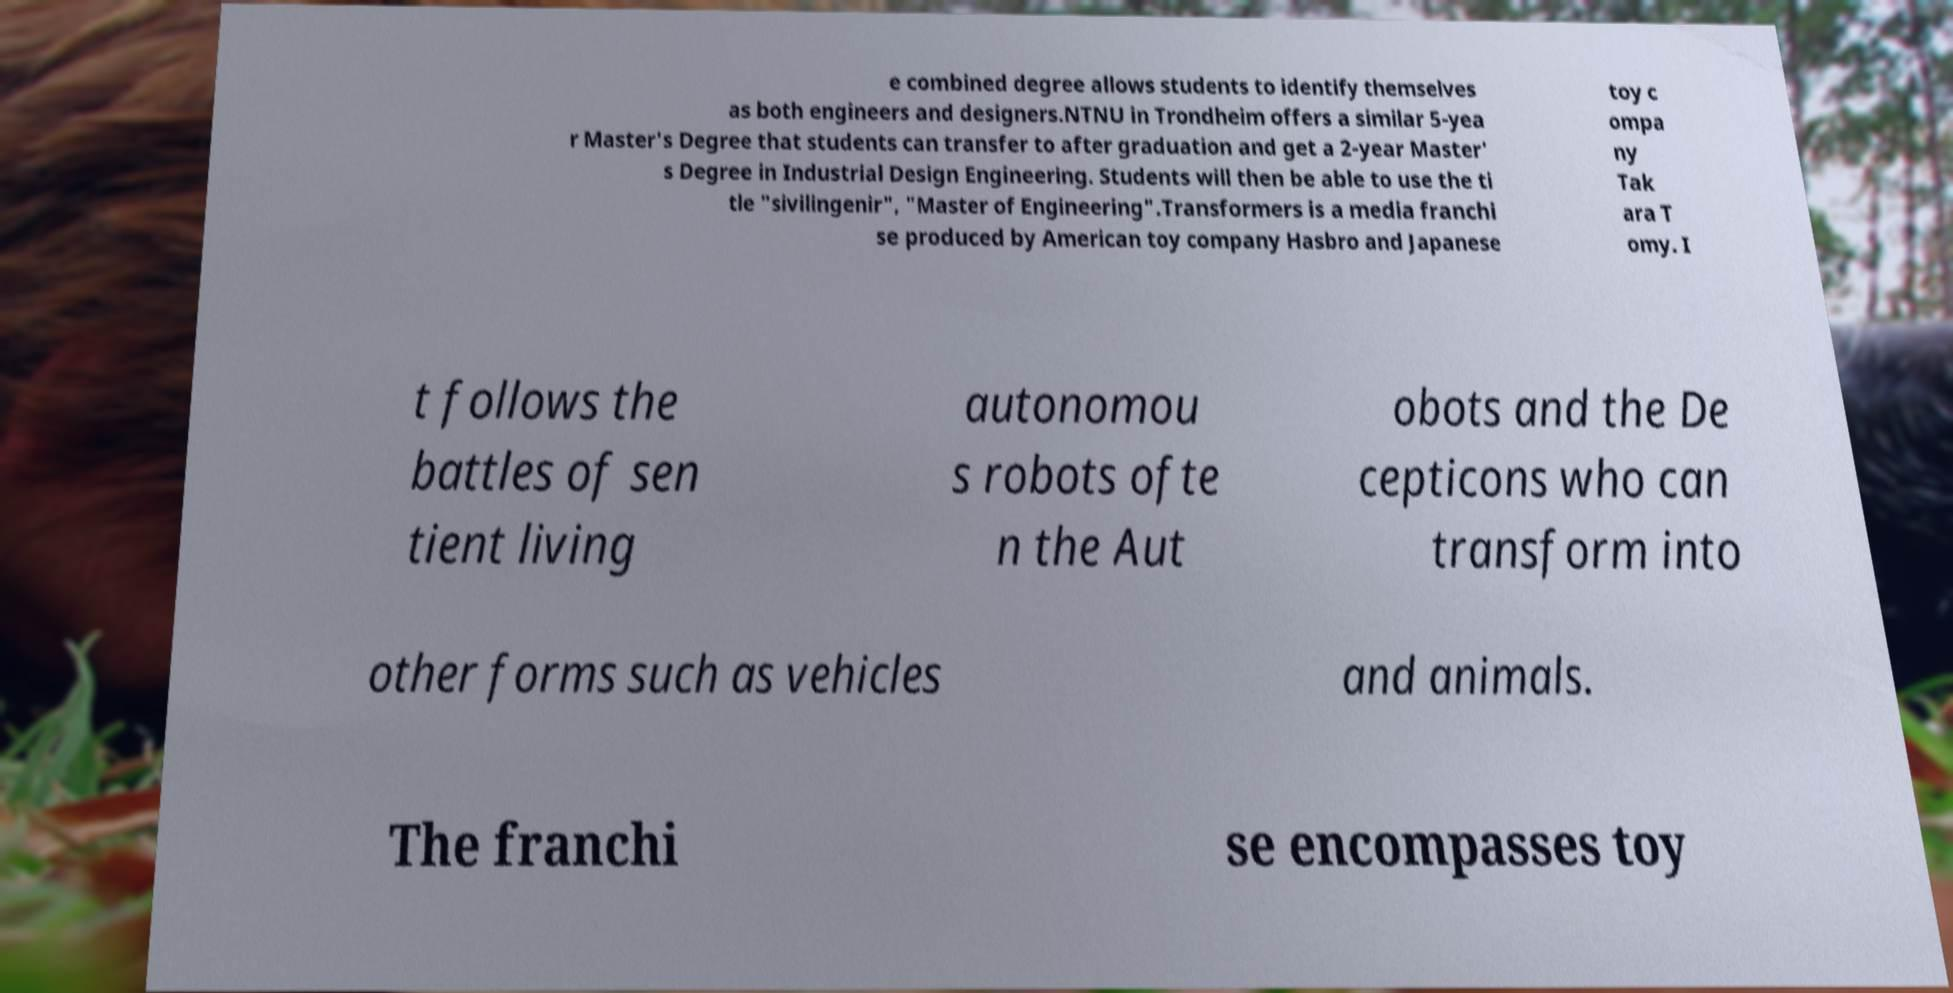Could you assist in decoding the text presented in this image and type it out clearly? e combined degree allows students to identify themselves as both engineers and designers.NTNU in Trondheim offers a similar 5-yea r Master's Degree that students can transfer to after graduation and get a 2-year Master' s Degree in Industrial Design Engineering. Students will then be able to use the ti tle "sivilingenir", "Master of Engineering".Transformers is a media franchi se produced by American toy company Hasbro and Japanese toy c ompa ny Tak ara T omy. I t follows the battles of sen tient living autonomou s robots ofte n the Aut obots and the De cepticons who can transform into other forms such as vehicles and animals. The franchi se encompasses toy 